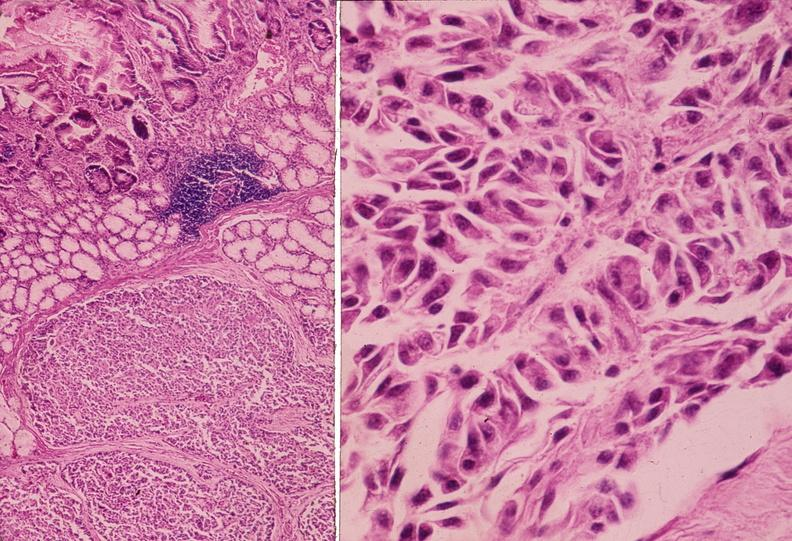what does this image show?
Answer the question using a single word or phrase. Islet cell tumor 